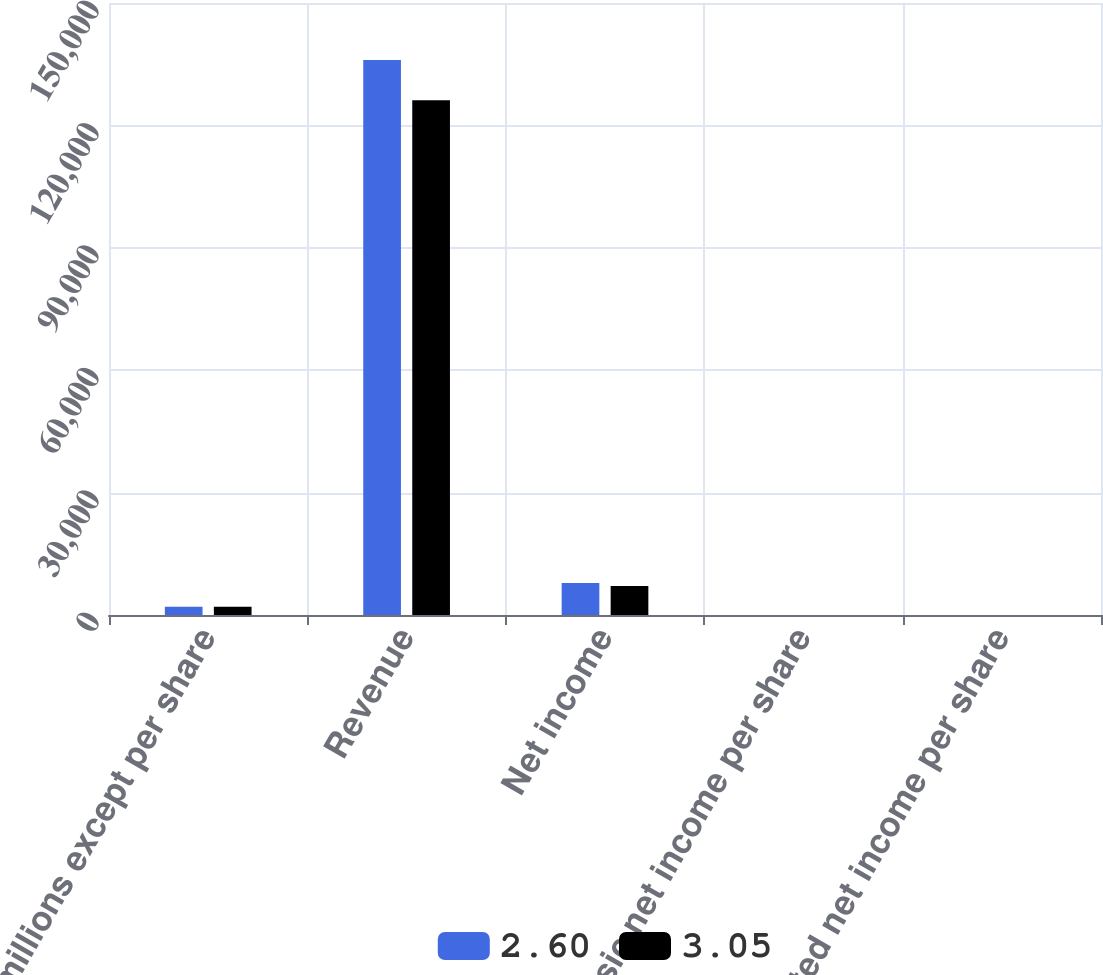Convert chart. <chart><loc_0><loc_0><loc_500><loc_500><stacked_bar_chart><ecel><fcel>In millions except per share<fcel>Revenue<fcel>Net income<fcel>Basic net income per share<fcel>Diluted net income per share<nl><fcel>2.6<fcel>2008<fcel>136022<fcel>7828<fcel>3.15<fcel>3.05<nl><fcel>3.05<fcel>2007<fcel>126178<fcel>7090<fcel>2.7<fcel>2.6<nl></chart> 